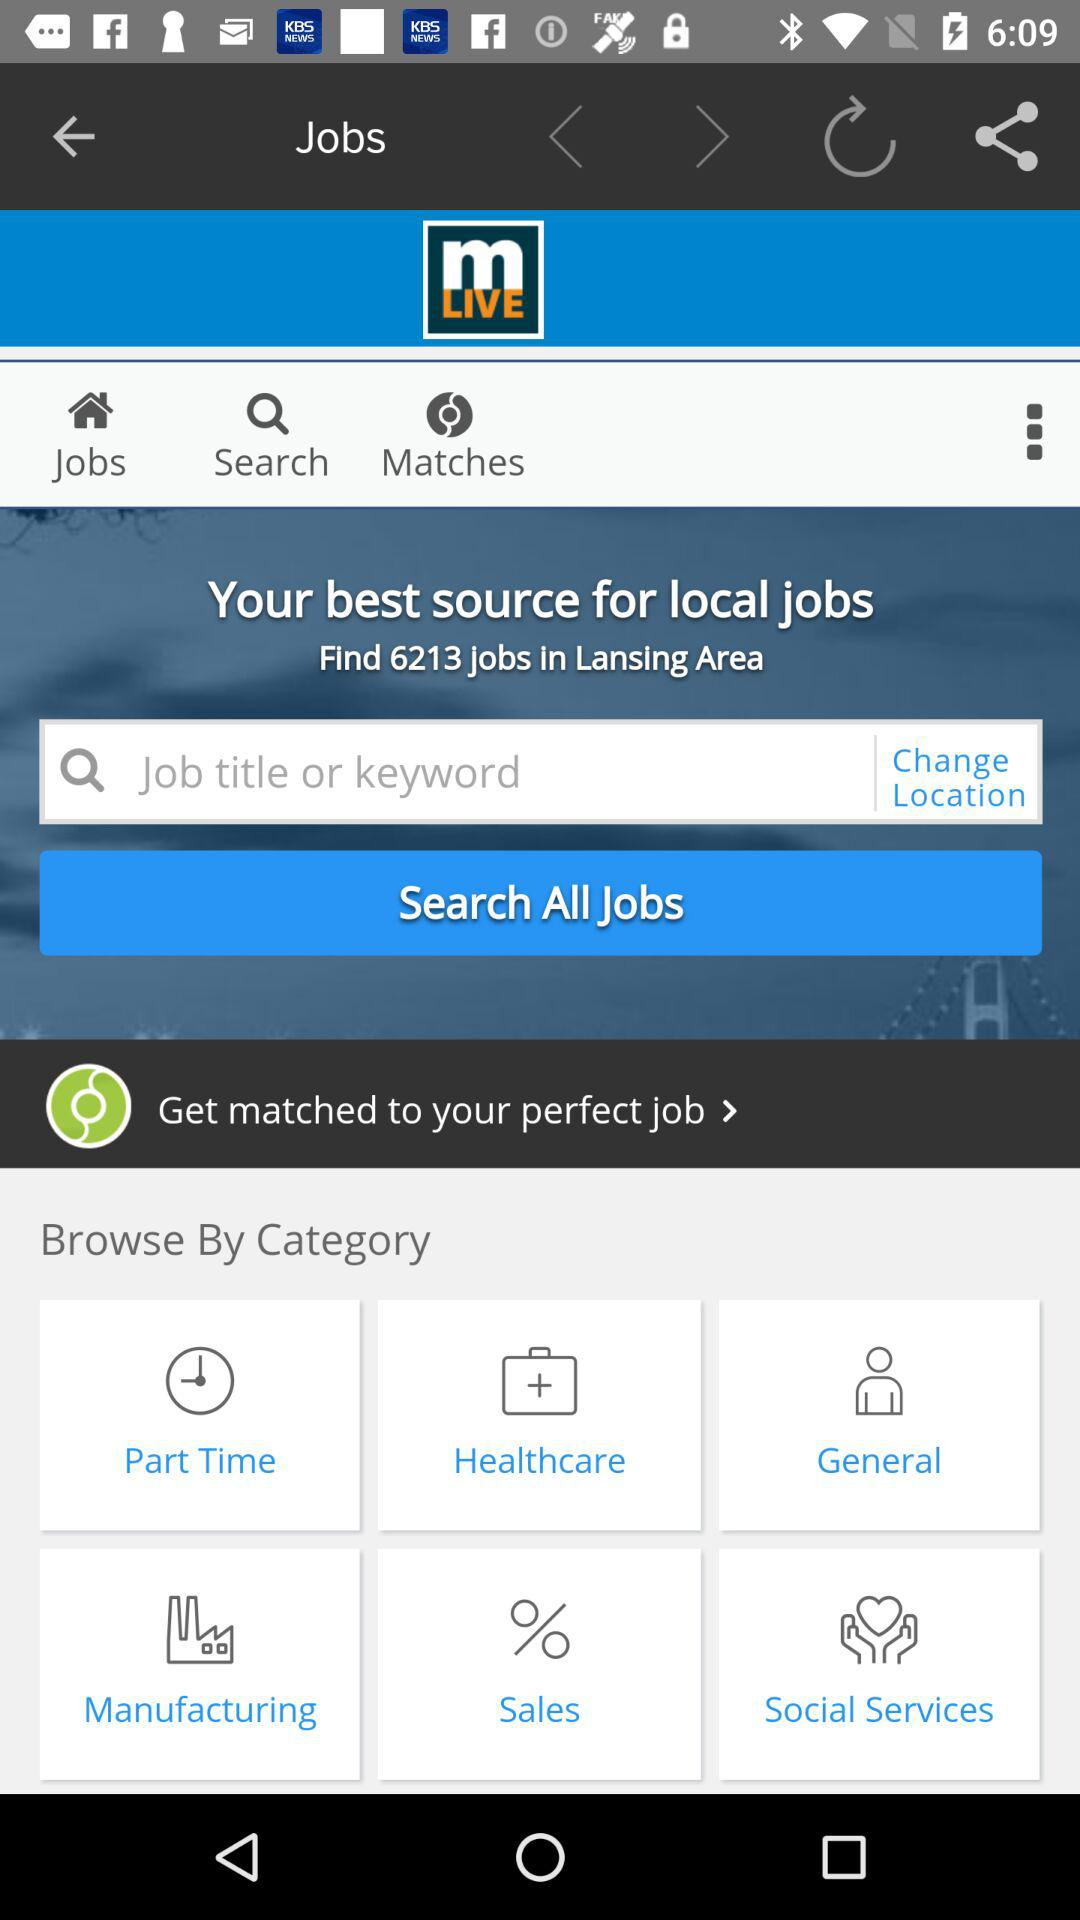How many jobs are available in Lansing Area?
Answer the question using a single word or phrase. 6213 